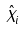<formula> <loc_0><loc_0><loc_500><loc_500>\hat { X } _ { i }</formula> 